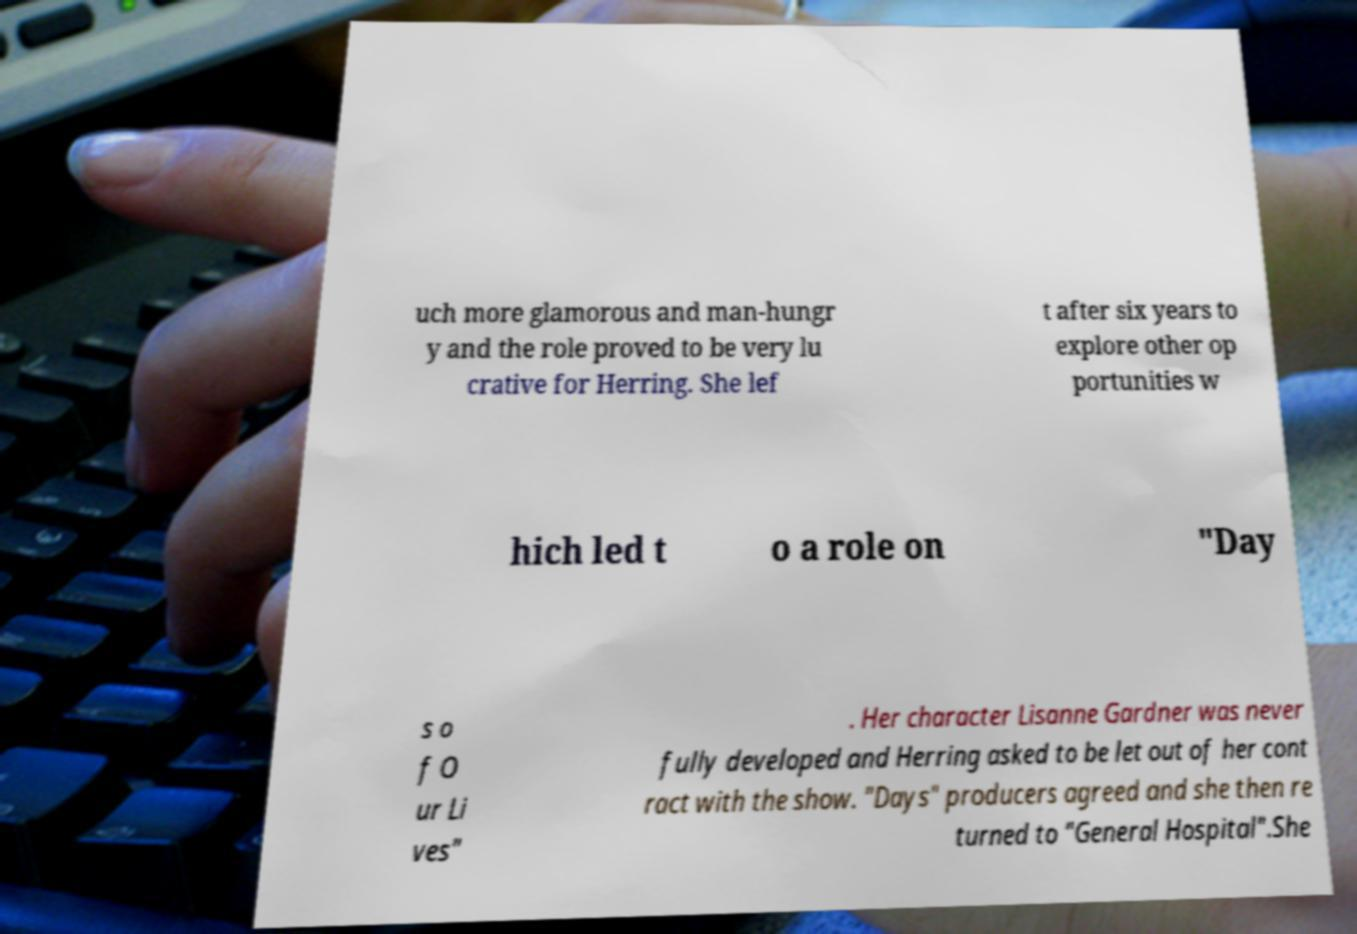I need the written content from this picture converted into text. Can you do that? uch more glamorous and man-hungr y and the role proved to be very lu crative for Herring. She lef t after six years to explore other op portunities w hich led t o a role on "Day s o f O ur Li ves" . Her character Lisanne Gardner was never fully developed and Herring asked to be let out of her cont ract with the show. "Days" producers agreed and she then re turned to "General Hospital".She 